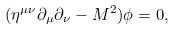<formula> <loc_0><loc_0><loc_500><loc_500>( \eta ^ { \mu \nu } \partial _ { \mu } \partial _ { \nu } - M ^ { 2 } ) \phi = 0 ,</formula> 